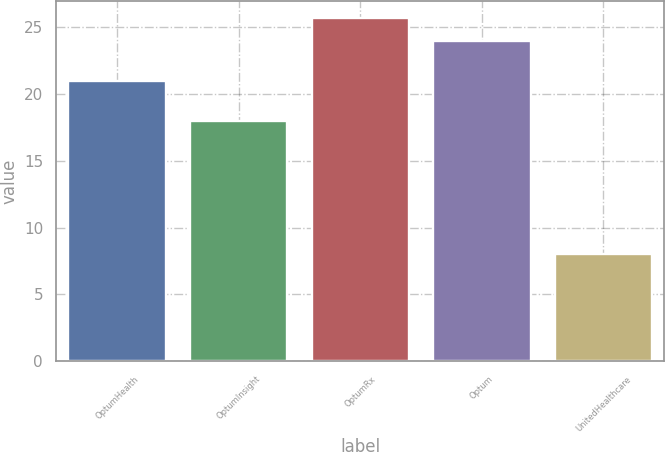Convert chart to OTSL. <chart><loc_0><loc_0><loc_500><loc_500><bar_chart><fcel>OptumHealth<fcel>OptumInsight<fcel>OptumRx<fcel>Optum<fcel>UnitedHealthcare<nl><fcel>21<fcel>18<fcel>25.7<fcel>24<fcel>8<nl></chart> 